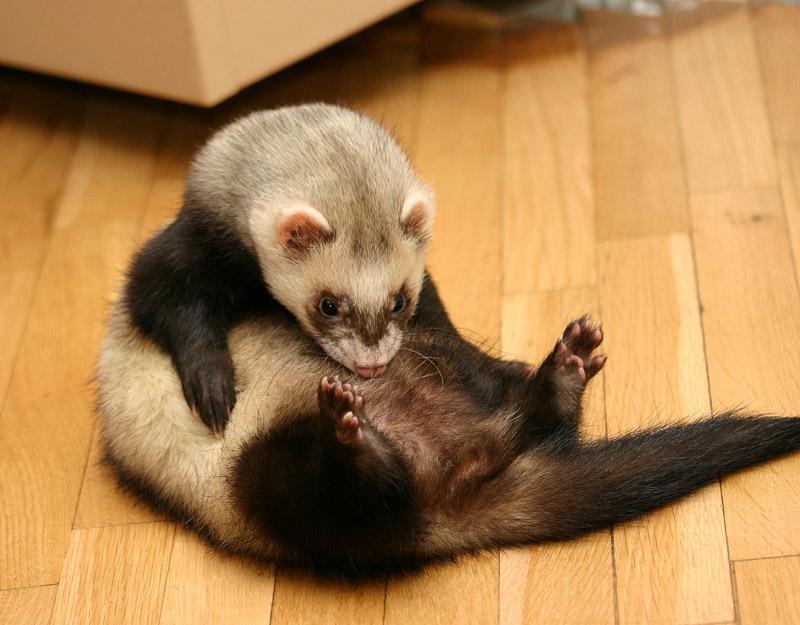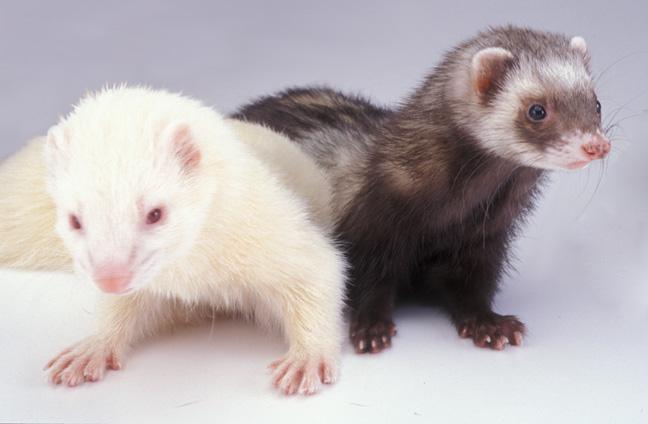The first image is the image on the left, the second image is the image on the right. Evaluate the accuracy of this statement regarding the images: "There are more animals in the image on the right.". Is it true? Answer yes or no. Yes. The first image is the image on the left, the second image is the image on the right. Analyze the images presented: Is the assertion "The right image contains exactly two ferrets." valid? Answer yes or no. Yes. 